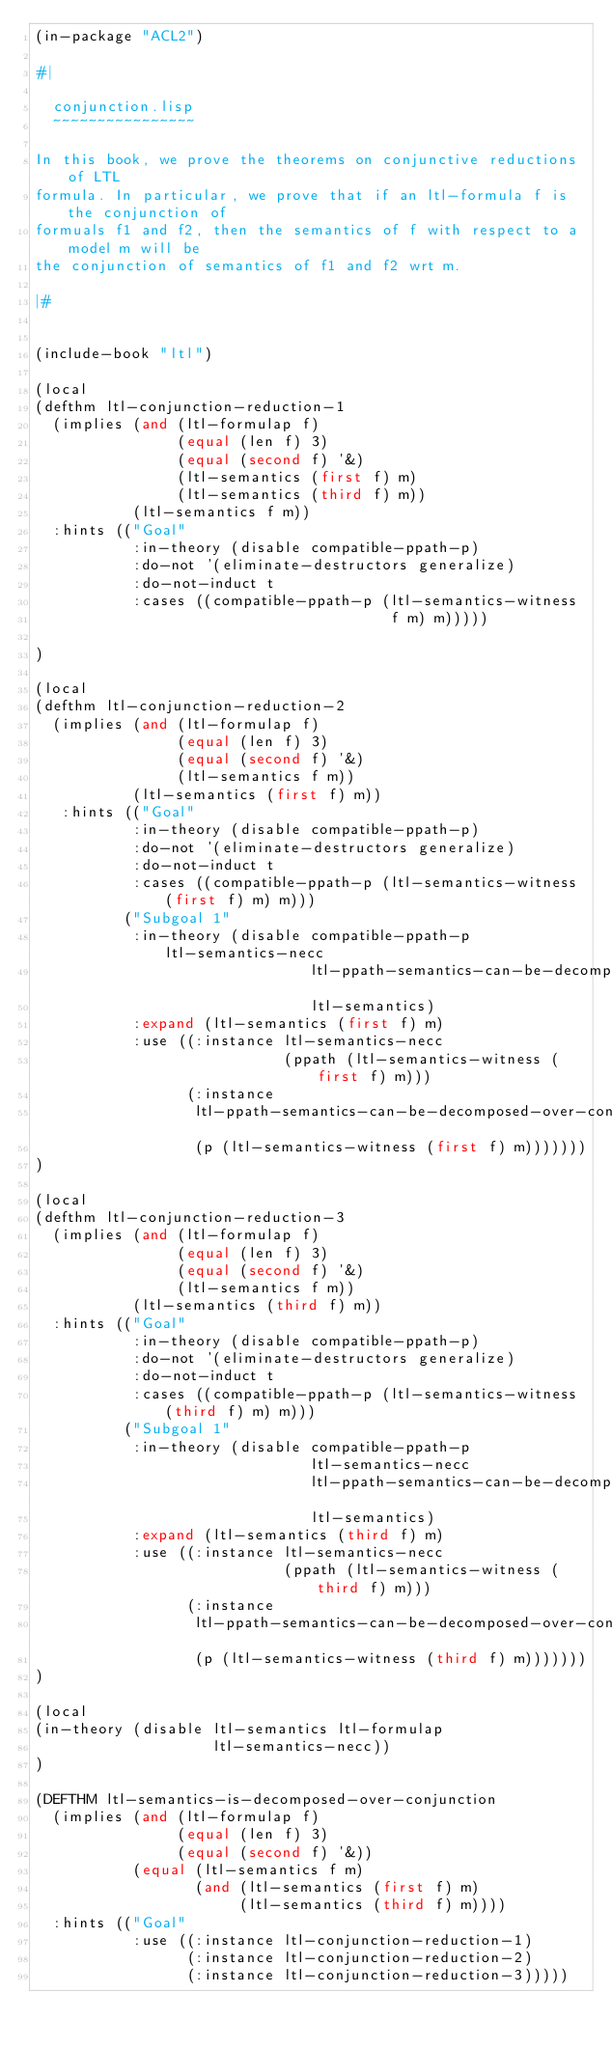Convert code to text. <code><loc_0><loc_0><loc_500><loc_500><_Lisp_>(in-package "ACL2")

#|

  conjunction.lisp
  ~~~~~~~~~~~~~~~~

In this book, we prove the theorems on conjunctive reductions of LTL
formula. In particular, we prove that if an ltl-formula f is the conjunction of
formuals f1 and f2, then the semantics of f with respect to a model m will be
the conjunction of semantics of f1 and f2 wrt m.

|#


(include-book "ltl")

(local
(defthm ltl-conjunction-reduction-1
  (implies (and (ltl-formulap f)
                (equal (len f) 3)
                (equal (second f) '&)
                (ltl-semantics (first f) m)
                (ltl-semantics (third f) m))
           (ltl-semantics f m))
  :hints (("Goal"
           :in-theory (disable compatible-ppath-p)
           :do-not '(eliminate-destructors generalize)
           :do-not-induct t
           :cases ((compatible-ppath-p (ltl-semantics-witness 
                                        f m) m)))))
     
)

(local
(defthm ltl-conjunction-reduction-2
  (implies (and (ltl-formulap f)
                (equal (len f) 3)
                (equal (second f) '&)
                (ltl-semantics f m))
           (ltl-semantics (first f) m))
   :hints (("Goal"
           :in-theory (disable compatible-ppath-p)
           :do-not '(eliminate-destructors generalize)
           :do-not-induct t
           :cases ((compatible-ppath-p (ltl-semantics-witness (first f) m) m)))
          ("Subgoal 1"
           :in-theory (disable compatible-ppath-p ltl-semantics-necc
                               ltl-ppath-semantics-can-be-decomposed-over-conjunctions
                               ltl-semantics)
           :expand (ltl-semantics (first f) m)
           :use ((:instance ltl-semantics-necc
                            (ppath (ltl-semantics-witness (first f) m)))
                 (:instance
                  ltl-ppath-semantics-can-be-decomposed-over-conjunctions
                  (p (ltl-semantics-witness (first f) m)))))))
)

(local
(defthm ltl-conjunction-reduction-3
  (implies (and (ltl-formulap f)
                (equal (len f) 3)
                (equal (second f) '&)
                (ltl-semantics f m))
           (ltl-semantics (third f) m))
  :hints (("Goal"
           :in-theory (disable compatible-ppath-p)
           :do-not '(eliminate-destructors generalize)
           :do-not-induct t
           :cases ((compatible-ppath-p (ltl-semantics-witness (third f) m) m)))
          ("Subgoal 1"
           :in-theory (disable compatible-ppath-p 
                               ltl-semantics-necc
                               ltl-ppath-semantics-can-be-decomposed-over-conjunctions
                               ltl-semantics)
           :expand (ltl-semantics (third f) m)
           :use ((:instance ltl-semantics-necc
                            (ppath (ltl-semantics-witness (third f) m)))
                 (:instance
                  ltl-ppath-semantics-can-be-decomposed-over-conjunctions
                  (p (ltl-semantics-witness (third f) m)))))))
)

(local
(in-theory (disable ltl-semantics ltl-formulap 
                    ltl-semantics-necc))
)

(DEFTHM ltl-semantics-is-decomposed-over-conjunction
  (implies (and (ltl-formulap f)
                (equal (len f) 3)
                (equal (second f) '&))
           (equal (ltl-semantics f m)
                  (and (ltl-semantics (first f) m)
                       (ltl-semantics (third f) m))))
  :hints (("Goal"
           :use ((:instance ltl-conjunction-reduction-1)
                 (:instance ltl-conjunction-reduction-2)
                 (:instance ltl-conjunction-reduction-3)))))
</code> 